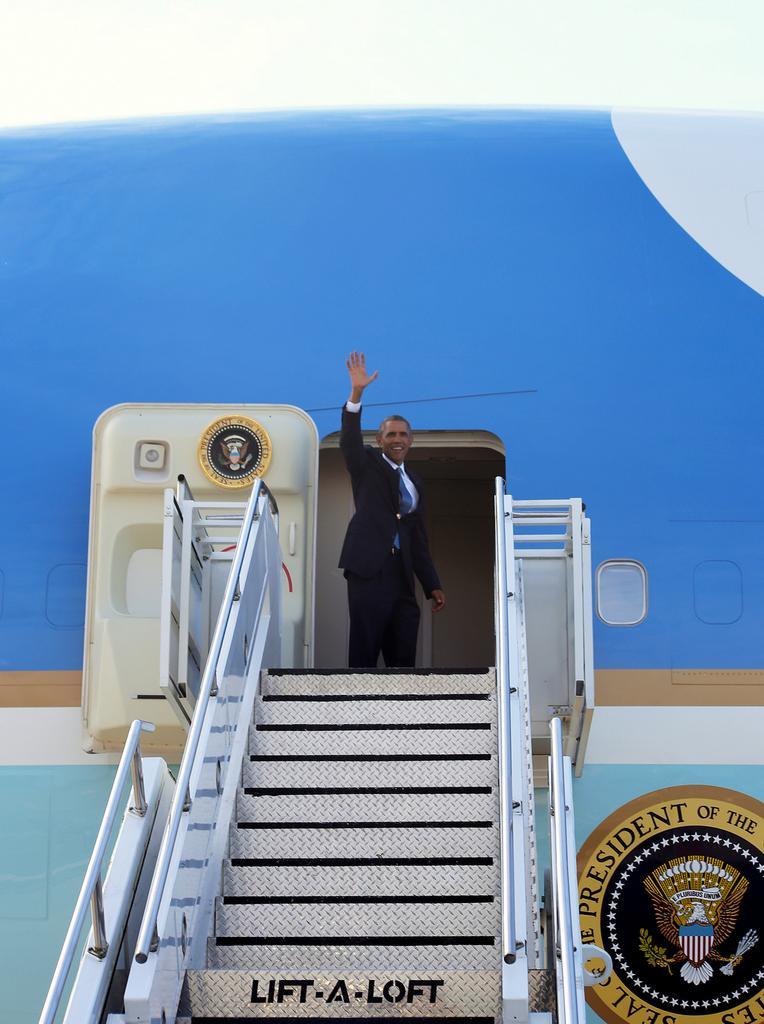In one or two sentences, can you explain what this image depicts? In this image we can see a person standing beside a door of an airplane. We can also see a staircase and a logo with some text on it. On the backside we can see the sky. 